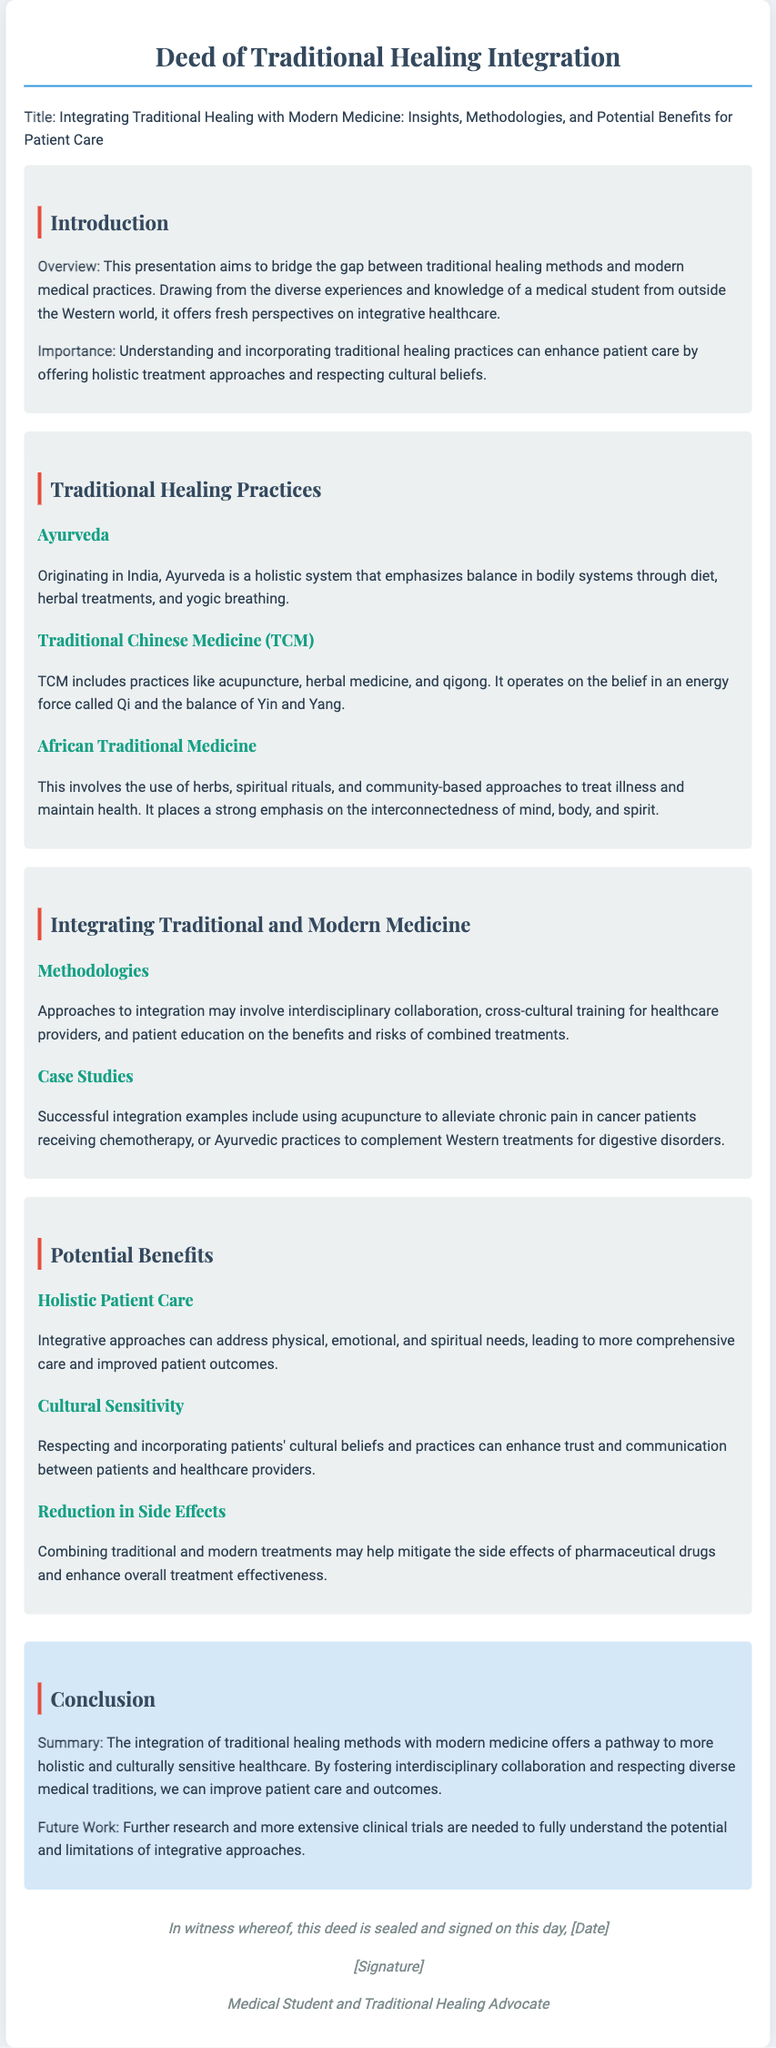What is the title of the presentation? The title is specifically mentioned in the document, focusing on the integration of traditional and modern medicine.
Answer: Integrating Traditional Healing with Modern Medicine: Insights, Methodologies, and Potential Benefits for Patient Care What healing practice originates in India? The document mentions Ayurveda as a healing practice originating in India.
Answer: Ayurveda What methodology involves interdisciplinary collaboration? The integration section discusses methodologies involving interdisciplinary collaboration among healthcare providers.
Answer: Interdisciplinary collaboration Which traditional medicine includes acupuncture? The document states that Traditional Chinese Medicine (TCM) includes acupuncture as one of its practices.
Answer: Traditional Chinese Medicine (TCM) What is one benefit of integrating traditional healing methods? The potential benefits section highlights holistic patient care as a significant advantage of integrative approaches.
Answer: Holistic Patient Care Who is the author of the document? The deed concludes with the signature section which identifies the author as a medical student and traditional healing advocate.
Answer: Medical Student and Traditional Healing Advocate What does TCM stand for? The acronym TCM is explicitly defined as Traditional Chinese Medicine in the document.
Answer: Traditional Chinese Medicine What is the emphasis of African Traditional Medicine? The document emphasizes the interconnectedness of mind, body, and spirit in African Traditional Medicine.
Answer: Interconnectedness of mind, body, and spirit 